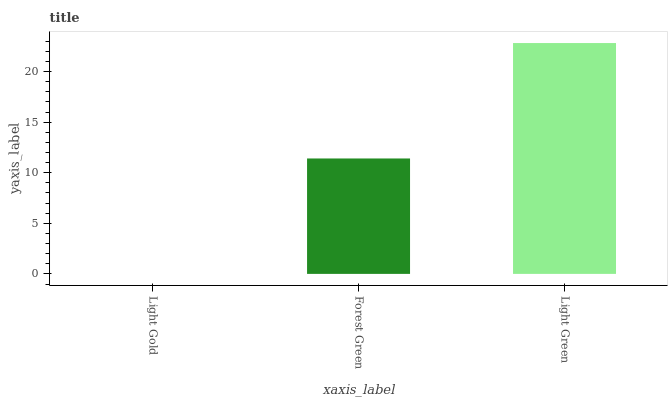Is Light Gold the minimum?
Answer yes or no. Yes. Is Light Green the maximum?
Answer yes or no. Yes. Is Forest Green the minimum?
Answer yes or no. No. Is Forest Green the maximum?
Answer yes or no. No. Is Forest Green greater than Light Gold?
Answer yes or no. Yes. Is Light Gold less than Forest Green?
Answer yes or no. Yes. Is Light Gold greater than Forest Green?
Answer yes or no. No. Is Forest Green less than Light Gold?
Answer yes or no. No. Is Forest Green the high median?
Answer yes or no. Yes. Is Forest Green the low median?
Answer yes or no. Yes. Is Light Green the high median?
Answer yes or no. No. Is Light Green the low median?
Answer yes or no. No. 